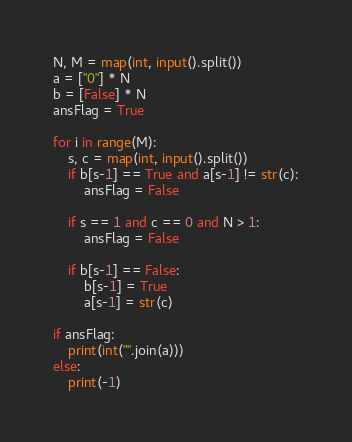<code> <loc_0><loc_0><loc_500><loc_500><_Python_>N, M = map(int, input().split())
a = ["0"] * N
b = [False] * N
ansFlag = True

for i in range(M):
    s, c = map(int, input().split())
    if b[s-1] == True and a[s-1] != str(c):
        ansFlag = False

    if s == 1 and c == 0 and N > 1:
        ansFlag = False

    if b[s-1] == False:
        b[s-1] = True
        a[s-1] = str(c)

if ansFlag:
    print(int("".join(a)))
else:
    print(-1)

</code> 